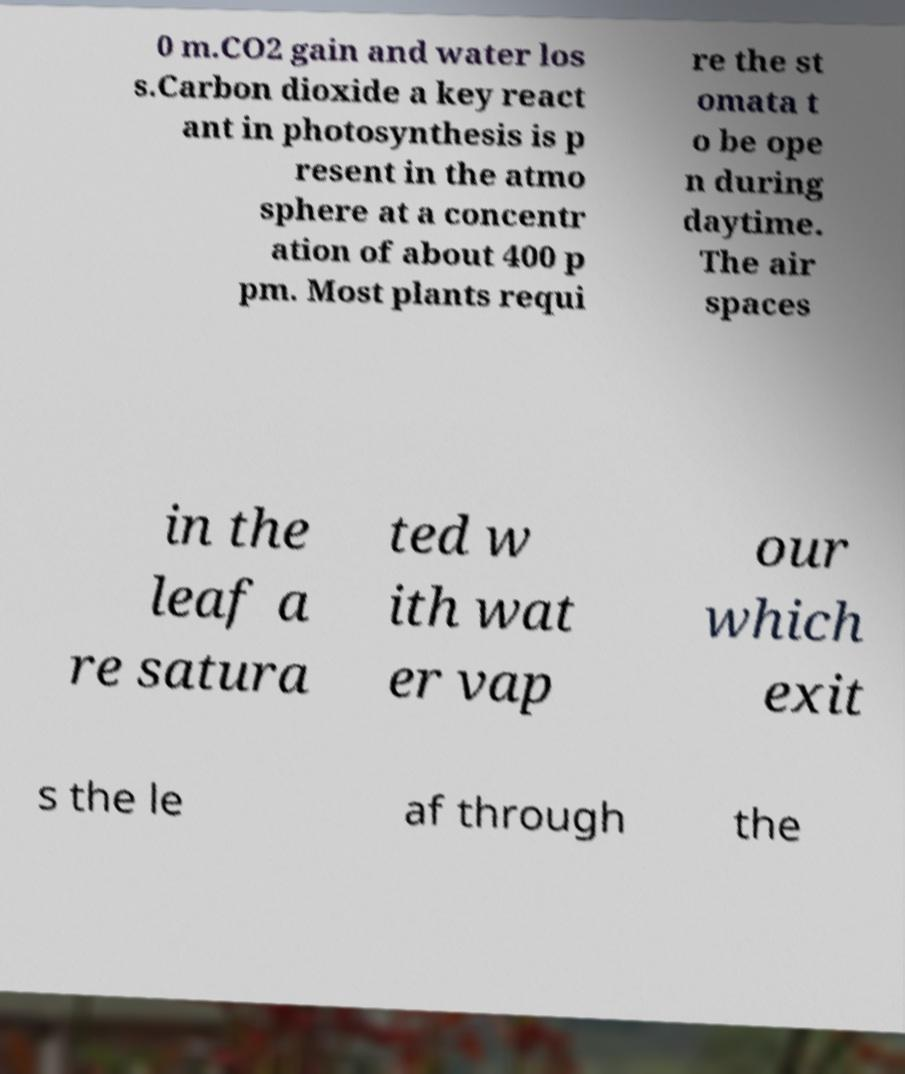What messages or text are displayed in this image? I need them in a readable, typed format. 0 m.CO2 gain and water los s.Carbon dioxide a key react ant in photosynthesis is p resent in the atmo sphere at a concentr ation of about 400 p pm. Most plants requi re the st omata t o be ope n during daytime. The air spaces in the leaf a re satura ted w ith wat er vap our which exit s the le af through the 